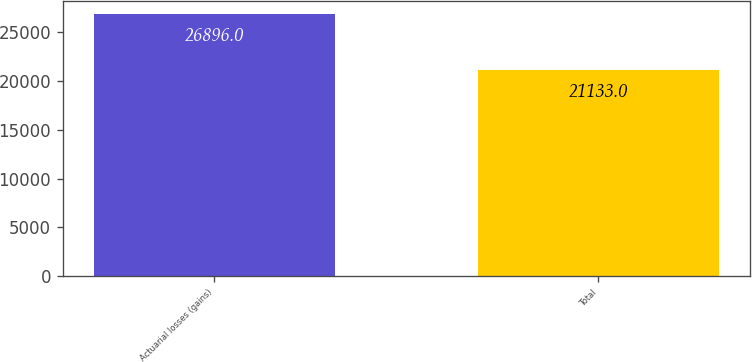<chart> <loc_0><loc_0><loc_500><loc_500><bar_chart><fcel>Actuarial losses (gains)<fcel>Total<nl><fcel>26896<fcel>21133<nl></chart> 